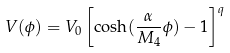<formula> <loc_0><loc_0><loc_500><loc_500>V ( \phi ) = V _ { 0 } \left [ \cosh ( \frac { \alpha } { M _ { 4 } } \phi ) - 1 \right ] ^ { q }</formula> 